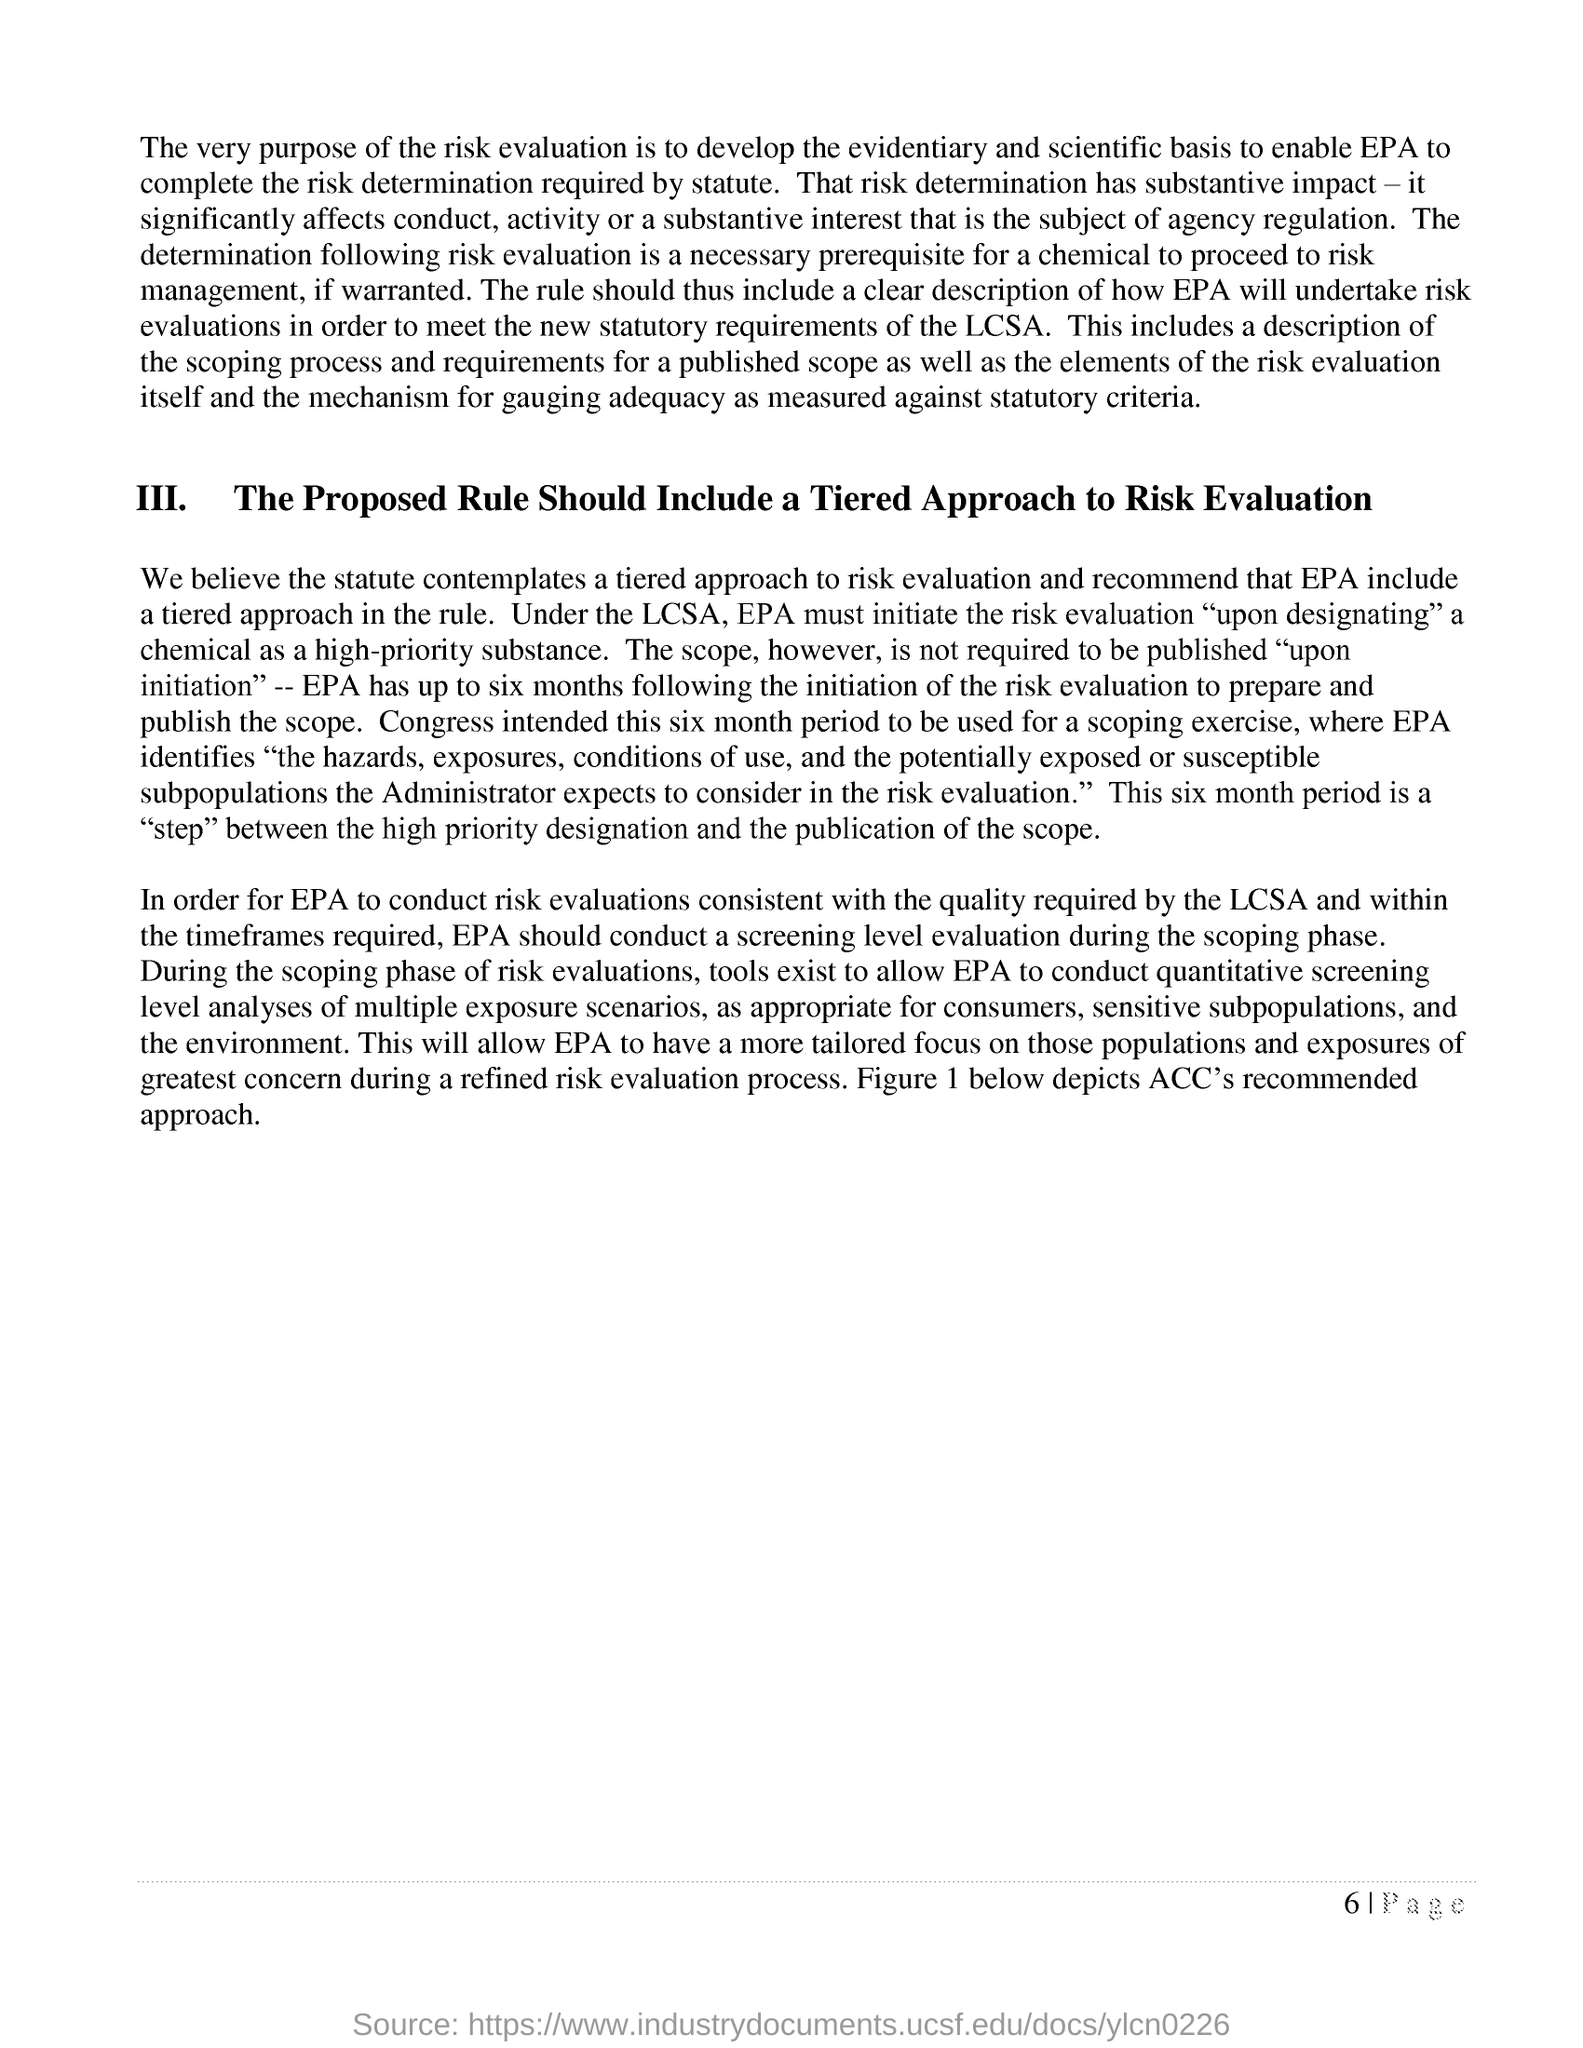What does Figure 1 below depicts?
Your answer should be very brief. Depicts acc's recommended approach. What is written in bold letters in the form of a heading?
Make the answer very short. III.   The Proposed Rule Should Include a Tiered Approach to Risk Evaluation. 